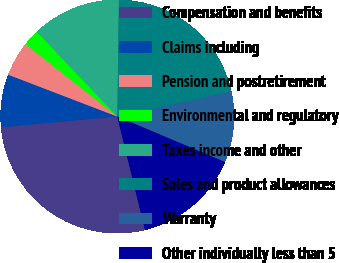Convert chart to OTSL. <chart><loc_0><loc_0><loc_500><loc_500><pie_chart><fcel>Compensation and benefits<fcel>Claims including<fcel>Pension and postretirement<fcel>Environmental and regulatory<fcel>Taxes income and other<fcel>Sales and product allowances<fcel>Warranty<fcel>Other individually less than 5<nl><fcel>27.35%<fcel>7.3%<fcel>4.79%<fcel>2.28%<fcel>12.31%<fcel>21.35%<fcel>9.8%<fcel>14.82%<nl></chart> 